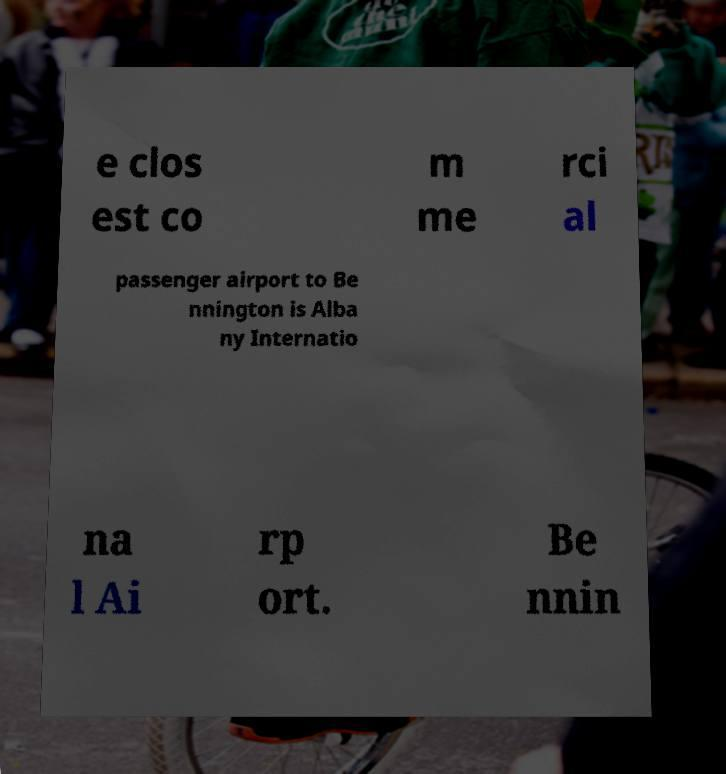Could you assist in decoding the text presented in this image and type it out clearly? e clos est co m me rci al passenger airport to Be nnington is Alba ny Internatio na l Ai rp ort. Be nnin 